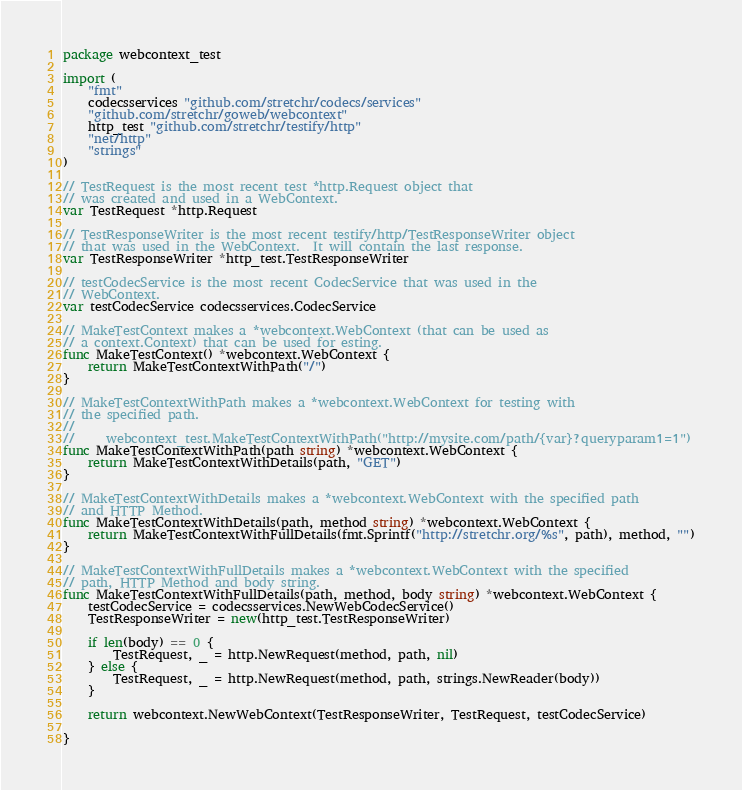Convert code to text. <code><loc_0><loc_0><loc_500><loc_500><_Go_>package webcontext_test

import (
	"fmt"
	codecsservices "github.com/stretchr/codecs/services"
	"github.com/stretchr/goweb/webcontext"
	http_test "github.com/stretchr/testify/http"
	"net/http"
	"strings"
)

// TestRequest is the most recent test *http.Request object that
// was created and used in a WebContext.
var TestRequest *http.Request

// TestResponseWriter is the most recent testify/http/TestResponseWriter object
// that was used in the WebContext.  It will contain the last response.
var TestResponseWriter *http_test.TestResponseWriter

// testCodecService is the most recent CodecService that was used in the
// WebContext.
var testCodecService codecsservices.CodecService

// MakeTestContext makes a *webcontext.WebContext (that can be used as
// a context.Context) that can be used for esting.
func MakeTestContext() *webcontext.WebContext {
	return MakeTestContextWithPath("/")
}

// MakeTestContextWithPath makes a *webcontext.WebContext for testing with
// the specified path.
//
//     webcontext_test.MakeTestContextWithPath("http://mysite.com/path/{var}?queryparam1=1")
func MakeTestContextWithPath(path string) *webcontext.WebContext {
	return MakeTestContextWithDetails(path, "GET")
}

// MakeTestContextWithDetails makes a *webcontext.WebContext with the specified path
// and HTTP Method.
func MakeTestContextWithDetails(path, method string) *webcontext.WebContext {
	return MakeTestContextWithFullDetails(fmt.Sprintf("http://stretchr.org/%s", path), method, "")
}

// MakeTestContextWithFullDetails makes a *webcontext.WebContext with the specified
// path, HTTP Method and body string.
func MakeTestContextWithFullDetails(path, method, body string) *webcontext.WebContext {
	testCodecService = codecsservices.NewWebCodecService()
	TestResponseWriter = new(http_test.TestResponseWriter)

	if len(body) == 0 {
		TestRequest, _ = http.NewRequest(method, path, nil)
	} else {
		TestRequest, _ = http.NewRequest(method, path, strings.NewReader(body))
	}

	return webcontext.NewWebContext(TestResponseWriter, TestRequest, testCodecService)

}
</code> 